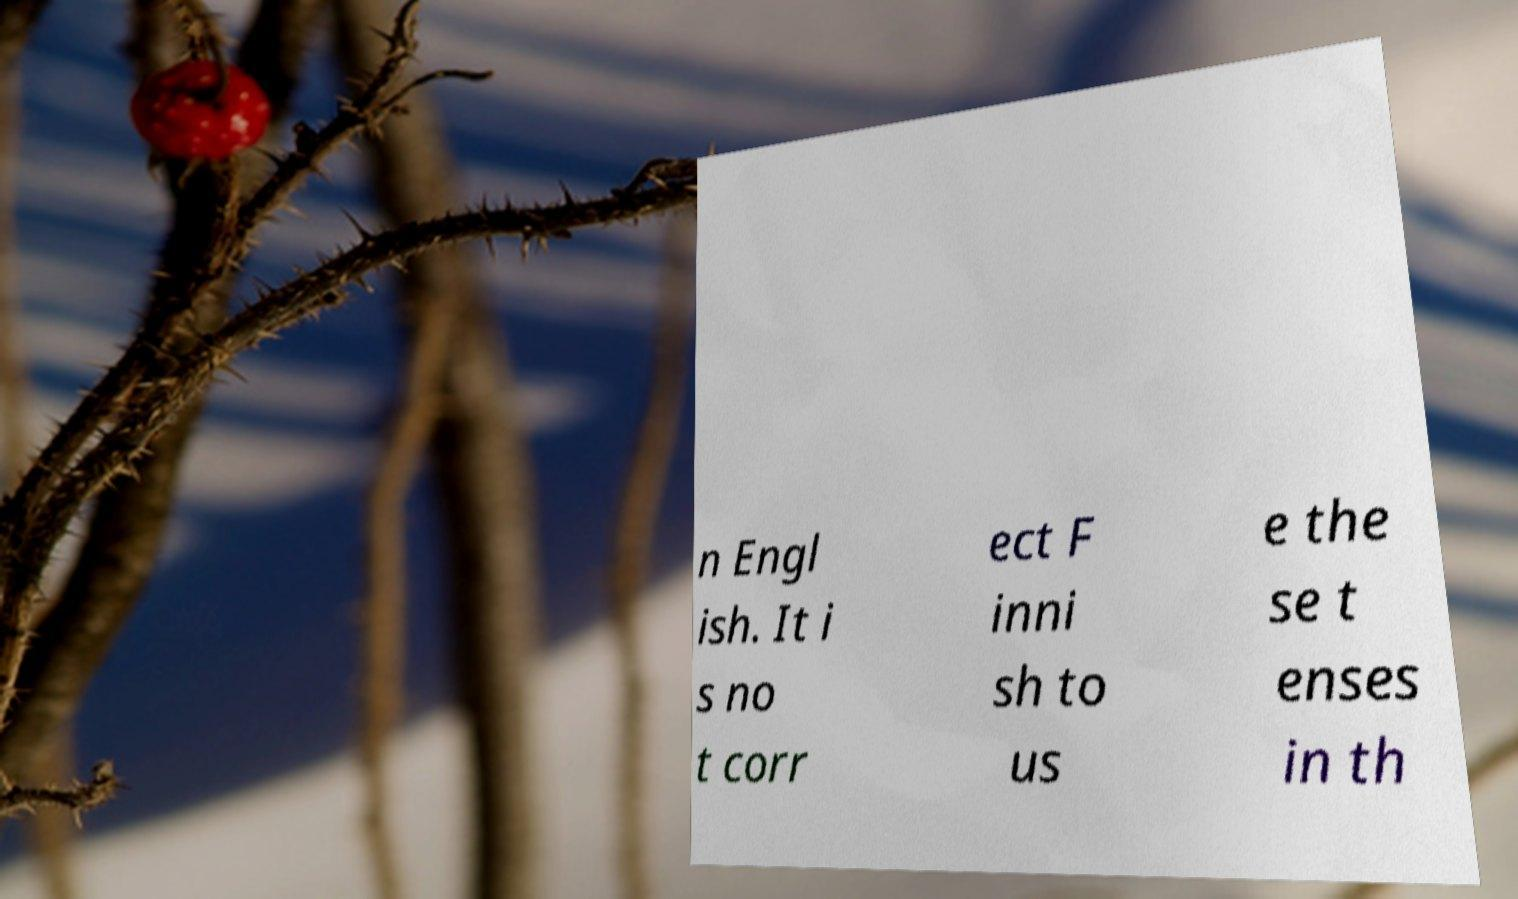For documentation purposes, I need the text within this image transcribed. Could you provide that? n Engl ish. It i s no t corr ect F inni sh to us e the se t enses in th 